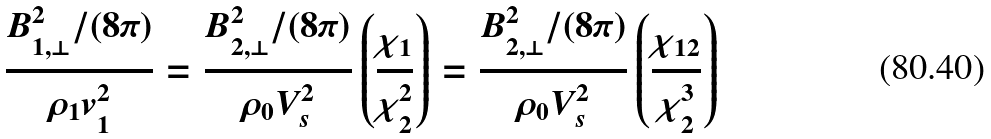Convert formula to latex. <formula><loc_0><loc_0><loc_500><loc_500>\frac { B _ { 1 , \perp } ^ { 2 } / ( 8 \pi ) } { \rho _ { 1 } v _ { 1 } ^ { 2 } } = \frac { B _ { 2 , \perp } ^ { 2 } / ( 8 \pi ) } { \rho _ { 0 } V _ { s } ^ { 2 } } \left ( \frac { \chi _ { 1 } } { \chi _ { 2 } ^ { 2 } } \right ) = \frac { B _ { 2 , \perp } ^ { 2 } / ( 8 \pi ) } { \rho _ { 0 } V _ { s } ^ { 2 } } \left ( \frac { \chi _ { 1 2 } } { \chi _ { 2 } ^ { 3 } } \right )</formula> 